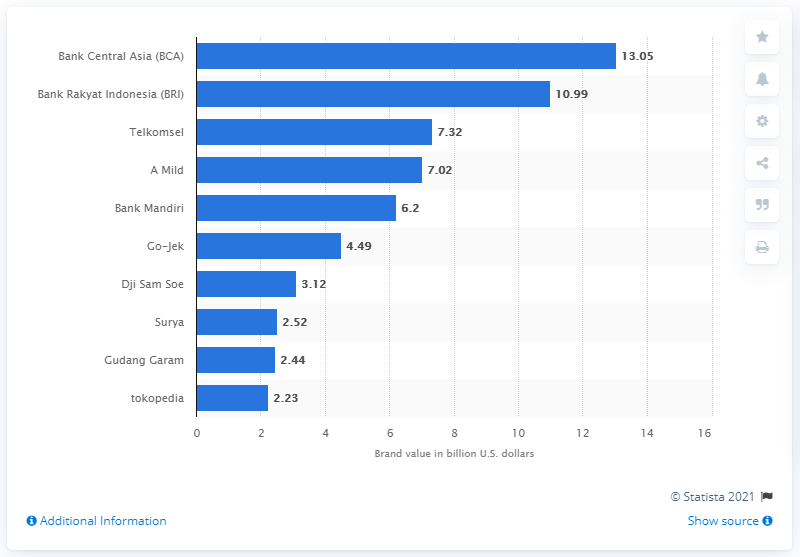Are there any companies related to telecommunications on this chart? Yes, there are telecommunications-related companies on the chart. Telkomsel appears to be related to telecommunications, given its name and brand value ranking. 